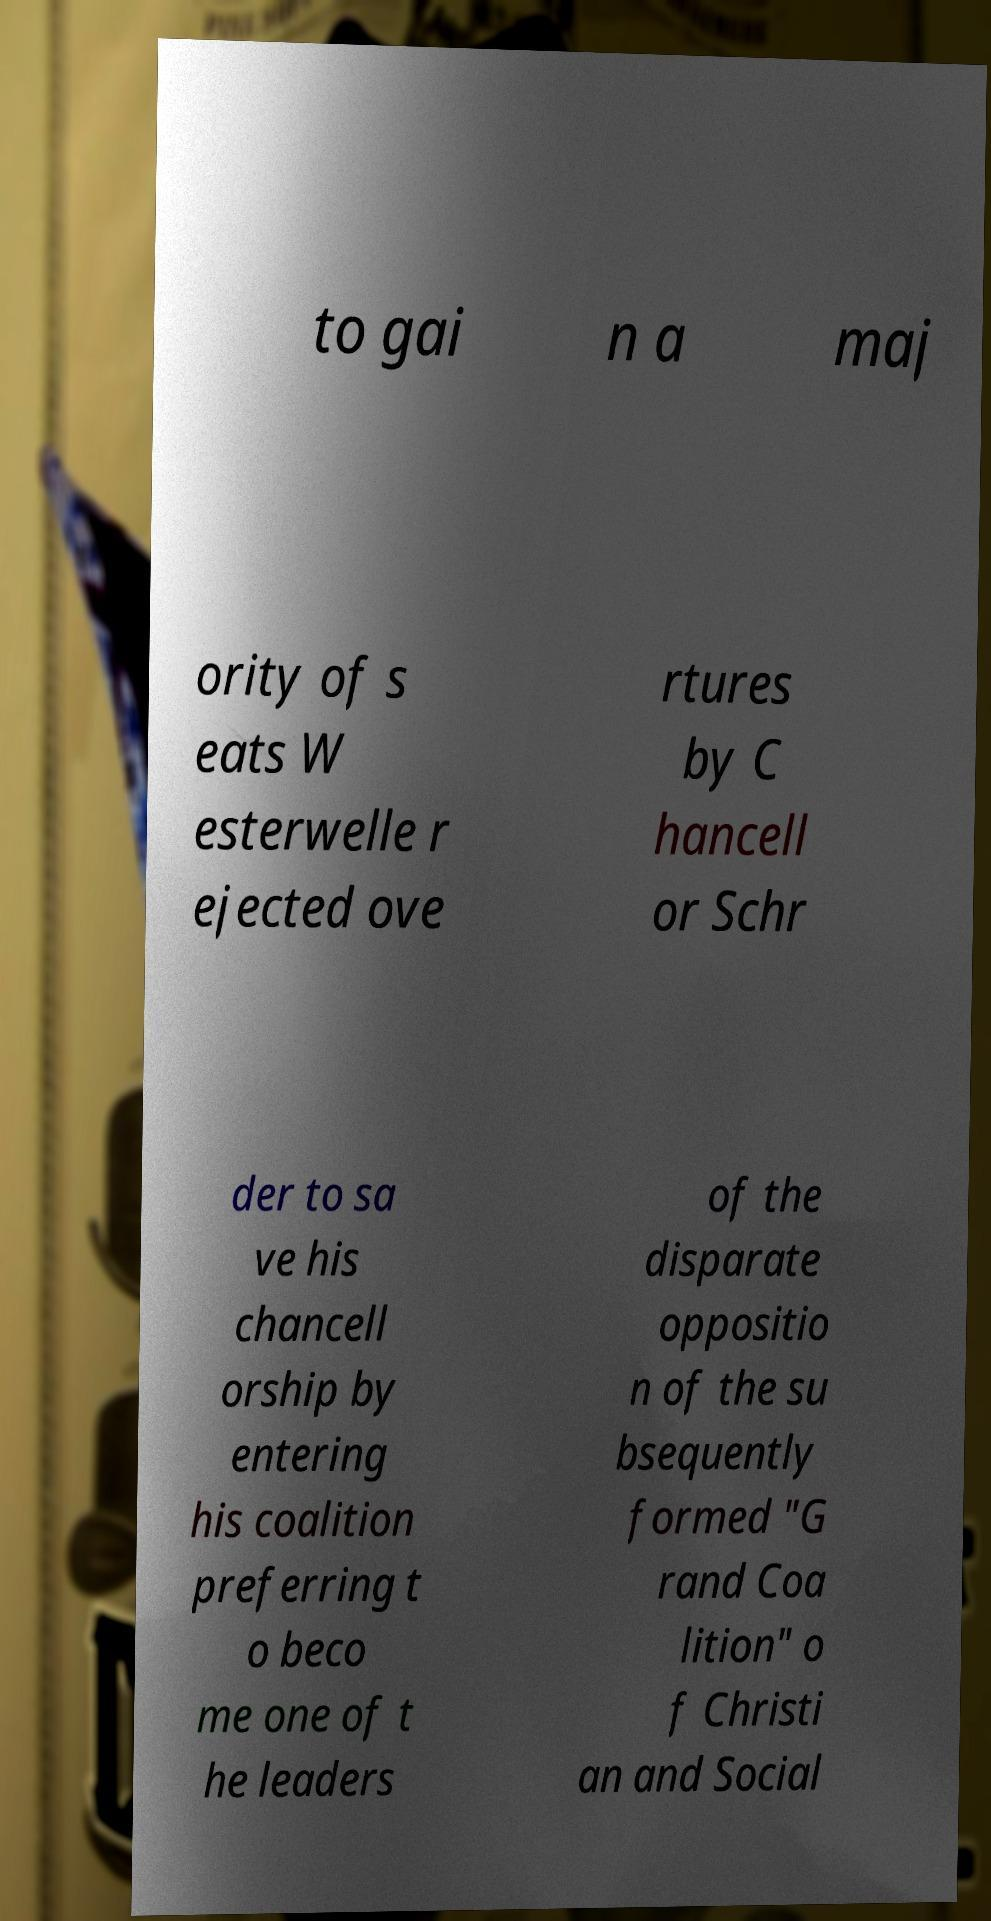Could you extract and type out the text from this image? to gai n a maj ority of s eats W esterwelle r ejected ove rtures by C hancell or Schr der to sa ve his chancell orship by entering his coalition preferring t o beco me one of t he leaders of the disparate oppositio n of the su bsequently formed "G rand Coa lition" o f Christi an and Social 